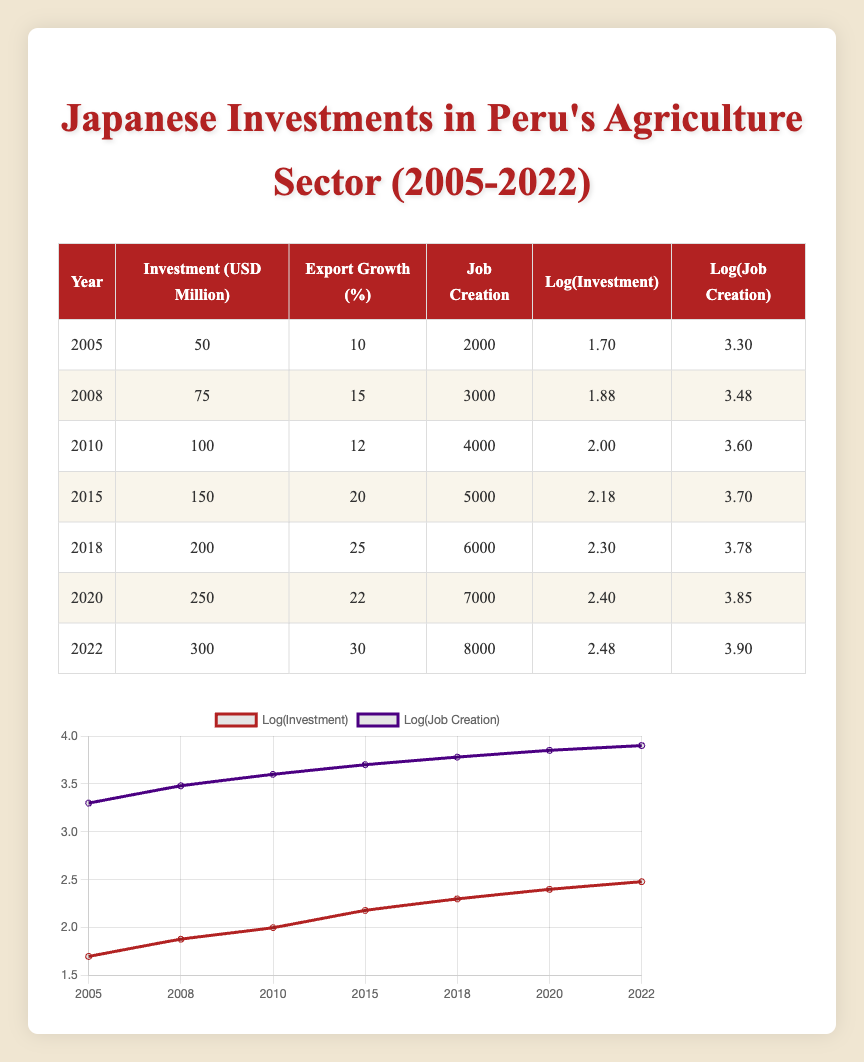What was the highest amount of Japanese investment in Peru's agriculture sector? The table shows that the highest investment amount is in 2022, which is 300 million USD.
Answer: 300 million USD What year saw the lowest export growth percentage? Looking at the table, the year with the lowest export growth percentage is 2010 at 12%.
Answer: 12% What is the total job creation from 2005 to 2022? To find the total job creation, sum all job creation values: 2000 + 3000 + 4000 + 5000 + 6000 + 7000 + 8000 = 31000.
Answer: 31000 Is it true that investments increased every three years? A review of the investment amounts shows that they increased regularly, specifically from 2005 to 2022 without any decrease, confirming that the investments increased every three years.
Answer: Yes What is the percentage increase in investment from 2005 to 2022? The investment in 2005 was 50 million USD and in 2022 was 300 million USD. Calculate the increase: (300 - 50) / 50 * 100 = 500%.
Answer: 500% Was there an increase in job creation from 2008 to 2010? By comparing the job creation from 2008 (3000) to 2010 (4000), we see an increase of 1000 jobs.
Answer: Yes What was the average export growth percentage from 2005 to 2022? Add the export growth percentages together: 10 + 15 + 12 + 20 + 25 + 22 + 30 = 134. Then, divide by 7 (the number of years): 134 / 7 ≈ 19.14%.
Answer: Approximately 19.14% Which year had a job creation value of 5000? The table indicates that the year with a job creation value of 5000 is 2015.
Answer: 2015 What growth in export percentage was observed between 2018 and 2020? The export growth percentage in 2018 was 25% and in 2020 it was 22%. This reflects a decrease of 3% over that period.
Answer: 3% decrease 